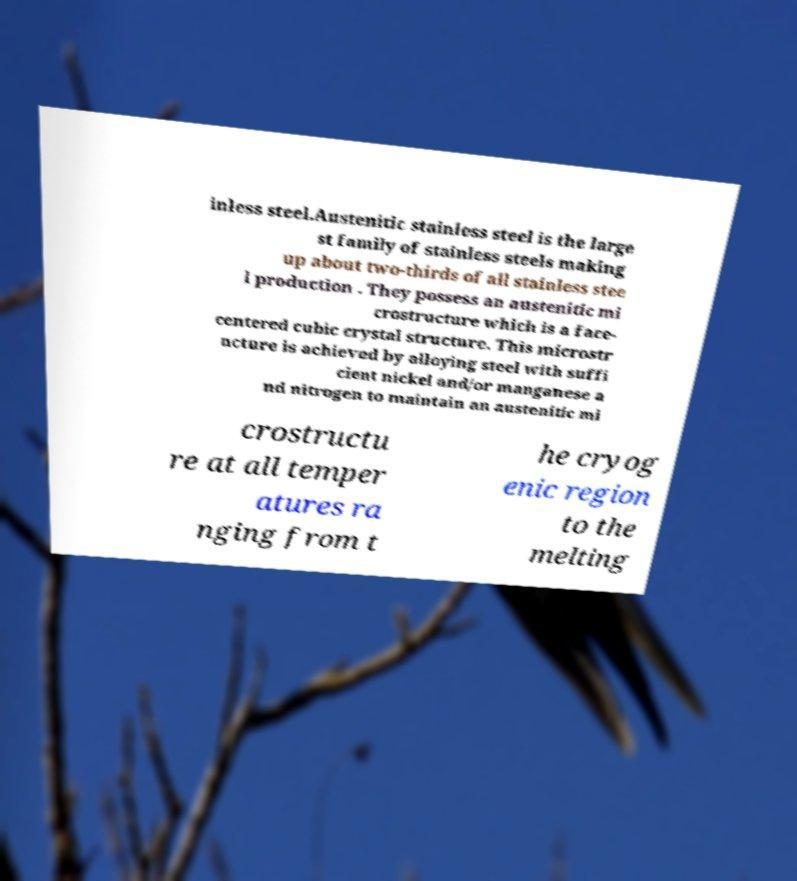Could you assist in decoding the text presented in this image and type it out clearly? inless steel.Austenitic stainless steel is the large st family of stainless steels making up about two-thirds of all stainless stee l production . They possess an austenitic mi crostructure which is a face- centered cubic crystal structure. This microstr ucture is achieved by alloying steel with suffi cient nickel and/or manganese a nd nitrogen to maintain an austenitic mi crostructu re at all temper atures ra nging from t he cryog enic region to the melting 